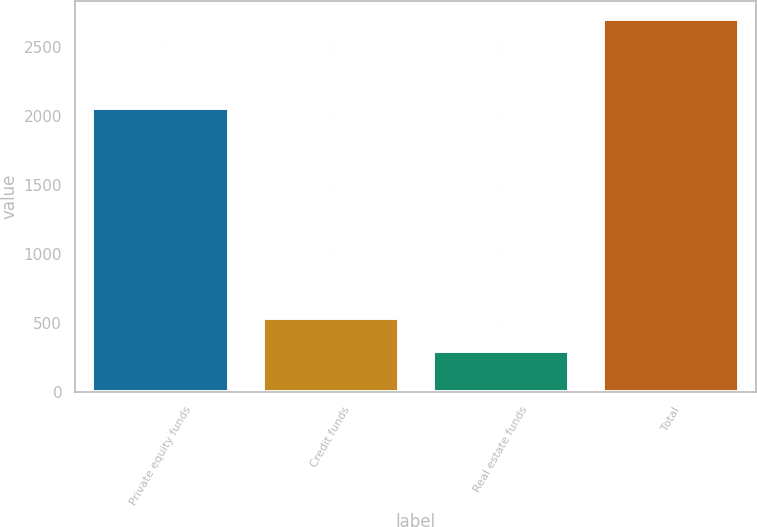Convert chart to OTSL. <chart><loc_0><loc_0><loc_500><loc_500><bar_chart><fcel>Private equity funds<fcel>Credit funds<fcel>Real estate funds<fcel>Total<nl><fcel>2057<fcel>536.1<fcel>296<fcel>2697<nl></chart> 